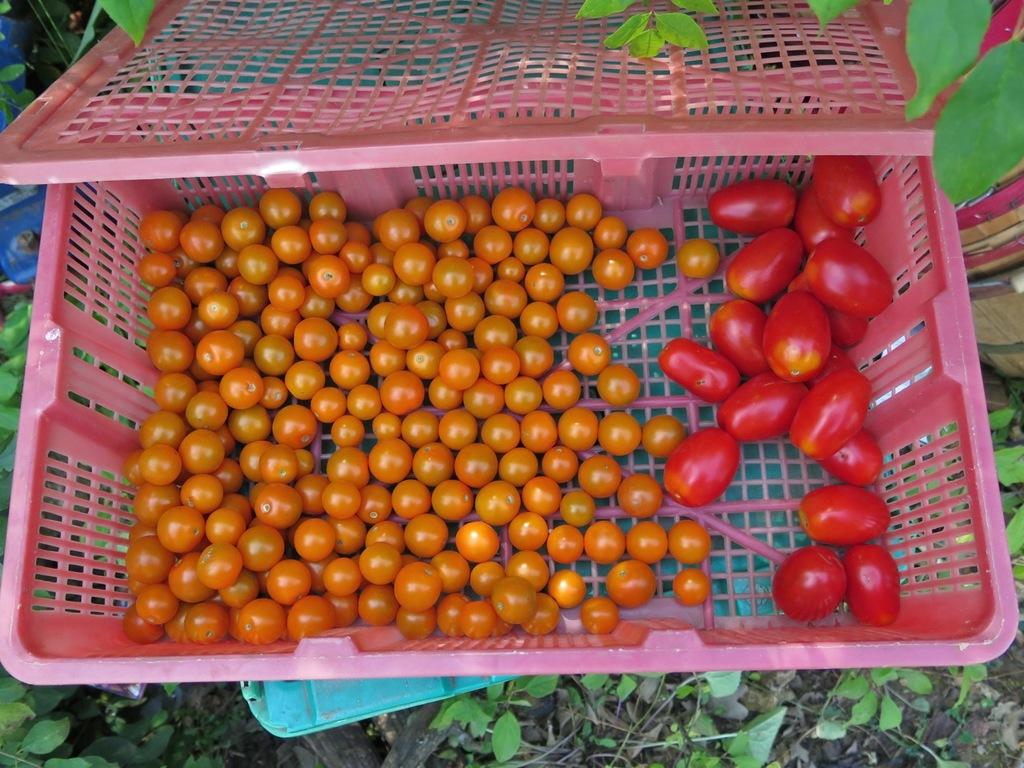What is in the basket that is visible in the image? There is a basket with tomatoes in the image. What type of vegetation can be seen in the image? There are plants visible in the image. What else can be found on the ground in the image? There are other objects on the ground in the image. What type of lettuce is growing in the image? There is no lettuce visible in the image; only tomatoes and other plants are present. 